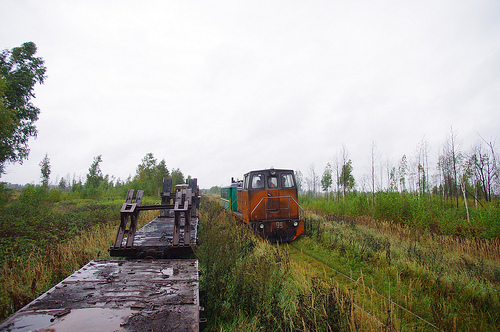What time of year does it appear to be in the image? Given the overgrown grass around the tracks and the absence of snow or people dressed for warm weather, it likely represents late spring to early autumn. The overcast sky and wet ground also hint at a season known for rain, such as late spring or early fall. 